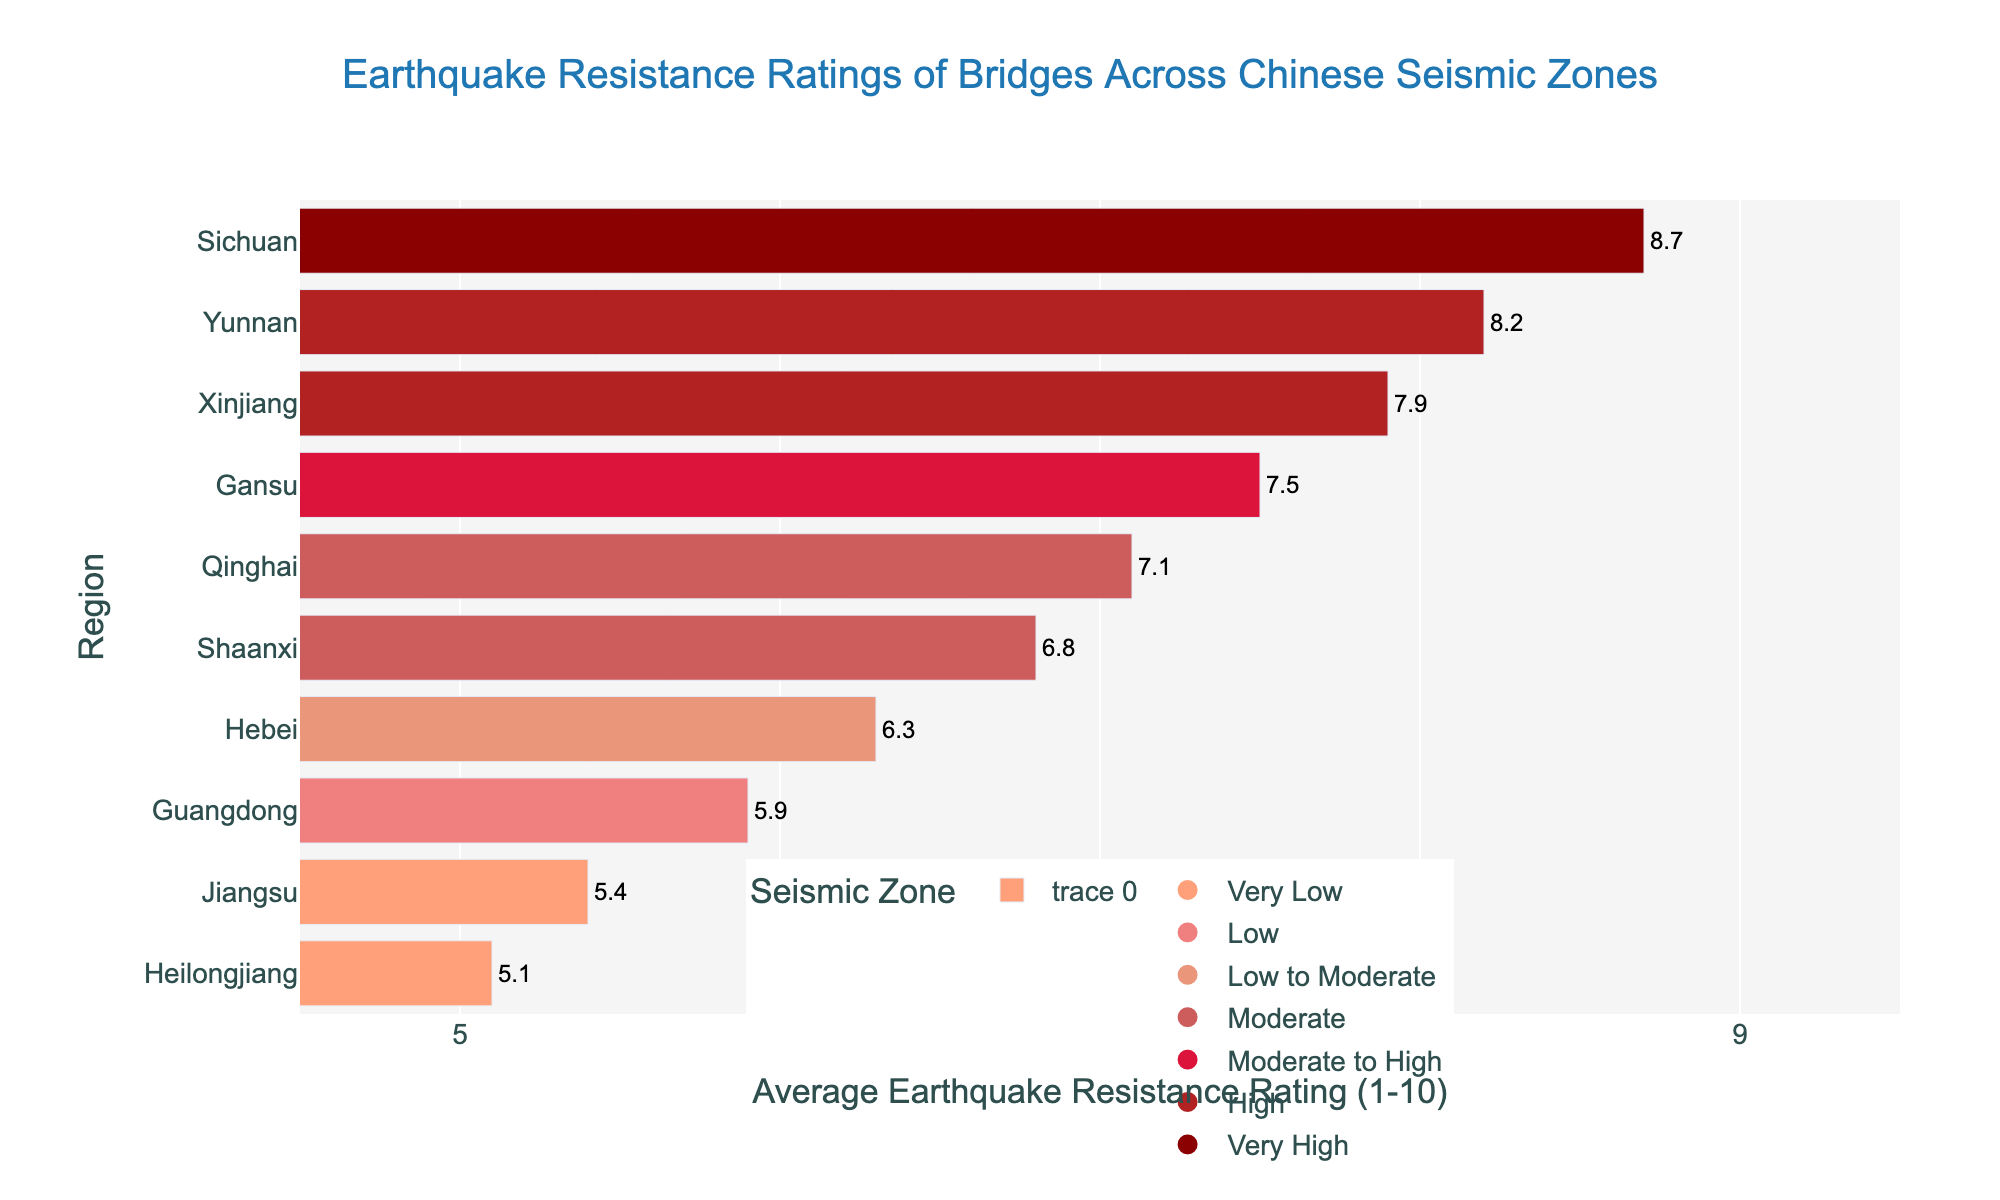Which region has the highest earthquake resistance rating for bridges? Sichuan has the highest average earthquake resistance rating of 8.7. By looking at the bar chart, Sichuan is the top bar, most extended in length, indicating the highest rating.
Answer: Sichuan Which region has the lowest earthquake resistance rating for bridges? Heilongjiang has the lowest average earthquake resistance rating of 5.1. By looking at the bar chart, Heilongjiang is the bottom bar, the shortest in length, indicating the lowest rating.
Answer: Heilongjiang What is the average earthquake resistance rating for bridges in the regions categorized as having a "High" seismic zone? The regions categorized as "High" seismic zone are Yunnan and Xinjiang, with ratings of 8.2 and 7.9, respectively. The average rating is calculated as (8.2 + 7.9)/2 = 8.05.
Answer: 8.05 Compare the earthquake resistance ratings between Sichuan and Yunnan. Which region has a higher rating and by how much? Sichuan has a rating of 8.7, and Yunnan has a rating of 8.2. The difference is 8.7 - 8.2 = 0.5. Sichuan has a higher rating by 0.5.
Answer: Sichuan by 0.5 What is the combined earthquake resistance rating of bridges for the regions in "Moderate" seismic zones? The regions in "Moderate" seismic zones are Qinghai and Shaanxi, with ratings of 7.1 and 6.8, respectively. The combined rating is 7.1 + 6.8 = 13.9.
Answer: 13.9 Which seismic zone has the most diverse range of earthquake resistance ratings, and what regions fall into that category? The "Moderate" seismic zone includes Qinghai (7.1) and Shaanxi (6.8), representing a range of 0.3. Other seismic zones show either less or no diversity.
Answer: Moderate What is the difference in earthquake resistance ratings between the regions with Very Low and Very High seismic zones? The region with Very Low seismic zones is Heilongjiang with a rating of 5.1, and the Very High seismic zone is Sichuan with a rating of 8.7. The difference is 8.7 - 5.1 = 3.6.
Answer: 3.6 How does the earthquake resistance rating for bridges in Hebei compare to that in Guangdong? Hebei has a rating of 6.3, and Guangdong has a rating of 5.9. Hebei's rating is 0.4 higher than Guangdong's.
Answer: Hebei by 0.4 What is the difference in average earthquake resistance ratings between the "Low" and "Moderate" seismic zones? The regions in "Low" seismic zone is Guangdong with a rating of 5.9. The regions in "Moderate" seismic zone are Qinghai and Shaanxi, with an average rating of (7.1 + 6.8)/2 = 6.95. The difference is 6.95 - 5.9 = 1.05.
Answer: 1.05 